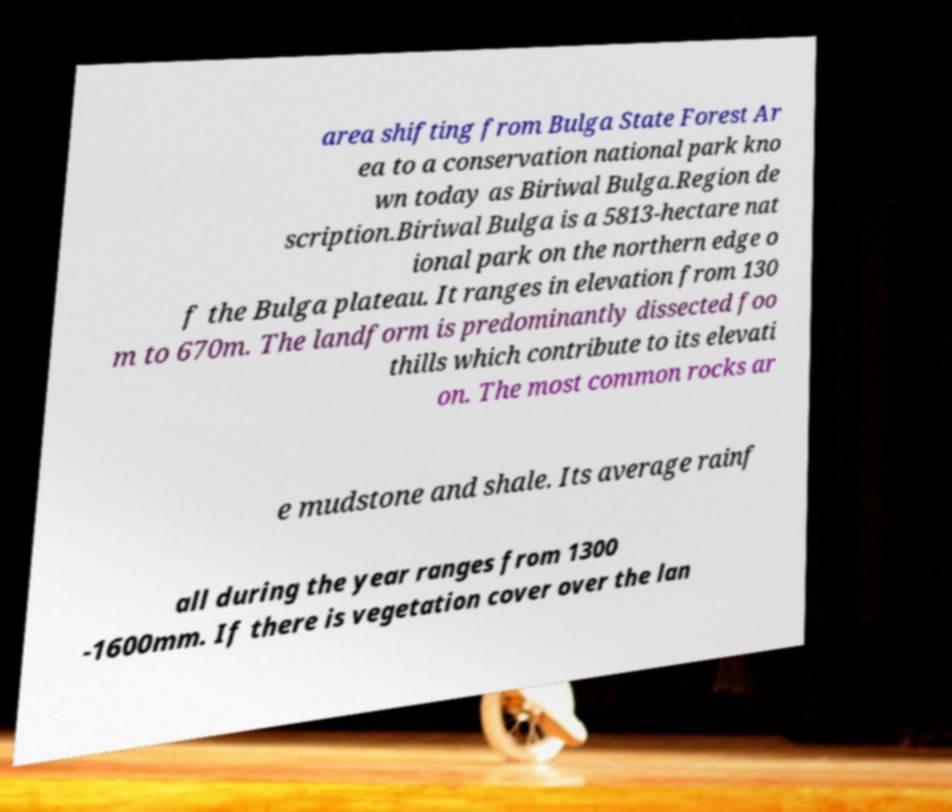What messages or text are displayed in this image? I need them in a readable, typed format. area shifting from Bulga State Forest Ar ea to a conservation national park kno wn today as Biriwal Bulga.Region de scription.Biriwal Bulga is a 5813-hectare nat ional park on the northern edge o f the Bulga plateau. It ranges in elevation from 130 m to 670m. The landform is predominantly dissected foo thills which contribute to its elevati on. The most common rocks ar e mudstone and shale. Its average rainf all during the year ranges from 1300 -1600mm. If there is vegetation cover over the lan 